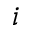Convert formula to latex. <formula><loc_0><loc_0><loc_500><loc_500>i</formula> 